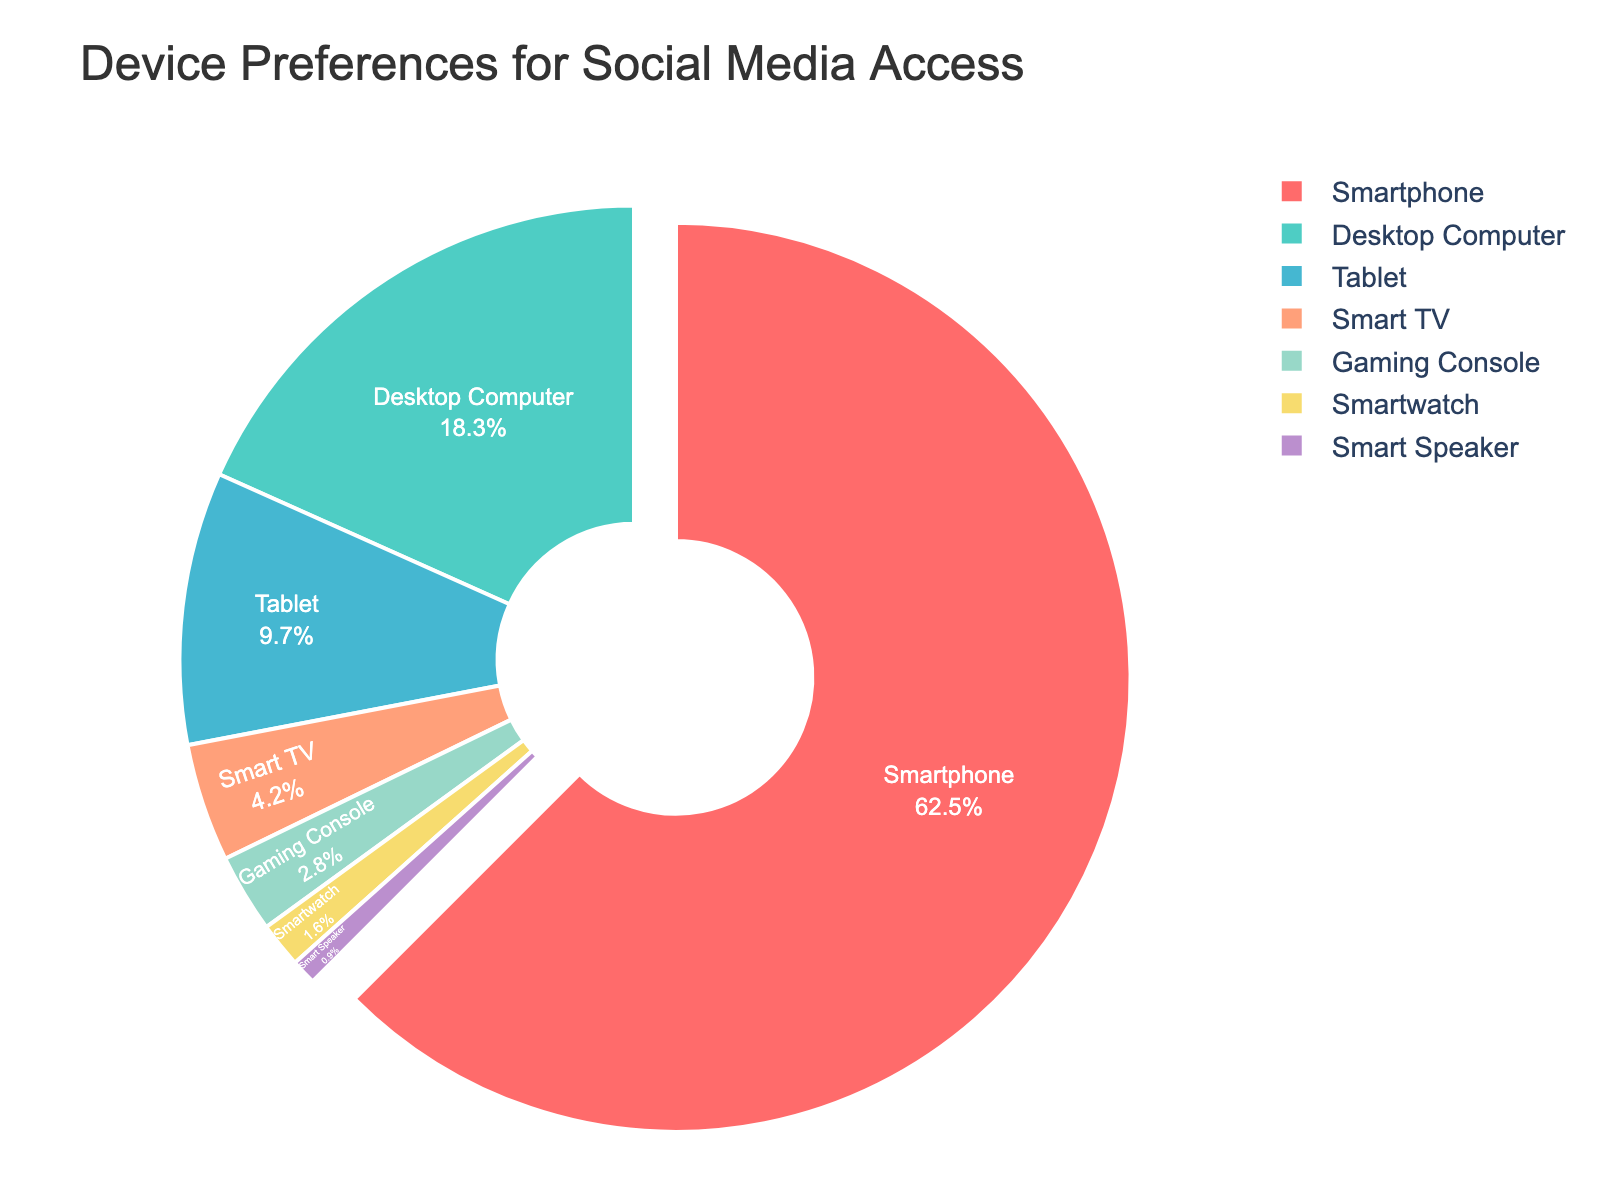What's the most preferred device for accessing the social media platform? The slice representing the "Smartphone" category is the largest in the pie chart, indicating it is the most preferred device. Smartphones have the highest percentage of 62.5%.
Answer: Smartphone Which device has the smallest share in the pie chart? To determine the smallest share, we look for the smallest slice in the pie chart. The "Smart Speaker" category has the smallest slice, with a percentage of 0.9%.
Answer: Smart Speaker How many devices have a larger percentage than the Tablet? By examining the pie chart, we identify slices larger than the "Tablet" category, which has 9.7%. The devices are "Smartphone" (62.5%) and "Desktop Computer" (18.3%). Thus, two devices have a larger percentage than the tablet.
Answer: 2 What is the combined percentage of Desktop Computer and Tablet usage? Add the percentages of the "Desktop Computer" (18.3%) and "Tablet" (9.7%) categories. 18.3% + 9.7% = 28%.
Answer: 28% Which devices have a percentage size between Smart TV and Smartwatch? "Smart TV" has 4.2% and "Smartwatch" has 1.6%. We look for percentages between these values. "Gaming Console" with 2.8% fits this criterion.
Answer: Gaming Console Is the percentage of users accessing the platform via Gaming Consoles greater than those accessing via Smart TVs? Compare the percentage of "Gaming Console" (2.8%) to the percentage of "Smart TV" (4.2%). 2.8% is less than 4.2%.
Answer: No Which device category has a teal-colored slice? The "Desktop Computer" slice is teal-colored.
Answer: Desktop Computer What percentage of users use either a Smartwatch or a Smart Speaker to access the platform? Add the percentages of "Smartwatch" (1.6%) and "Smart Speaker" (0.9%). 1.6% + 0.9% = 2.5%.
Answer: 2.5% How much higher is the percentage of users accessing via Smartphones compared to Desktop Computers? Subtract the percentage of "Desktop Computer" (18.3%) from "Smartphone" (62.5%). 62.5% - 18.3% = 44.2%.
Answer: 44.2% What is the second most popular device for accessing the platform? The "Desktop Computer" category has the second-largest slice after "Smartphone."
Answer: Desktop Computer 